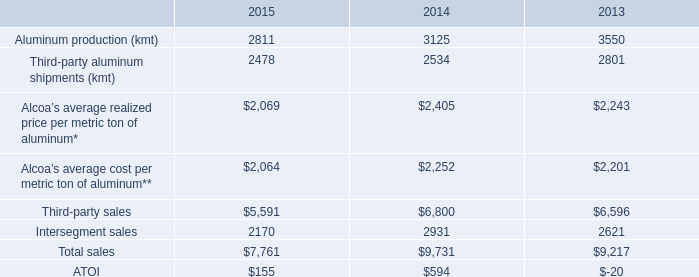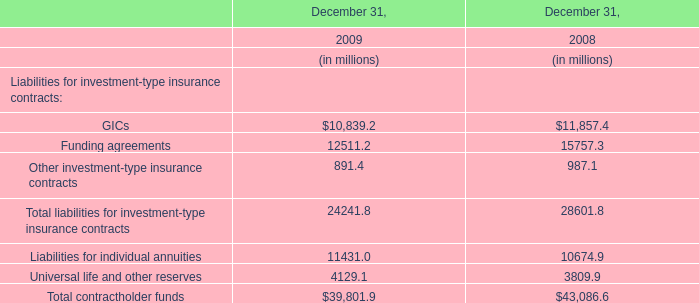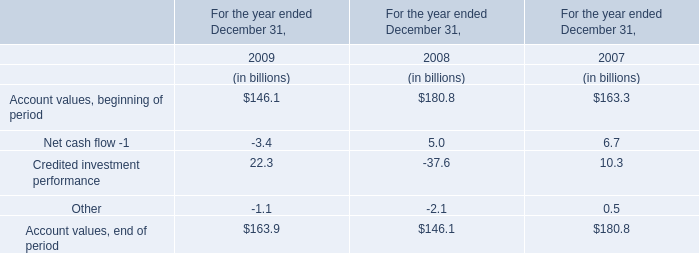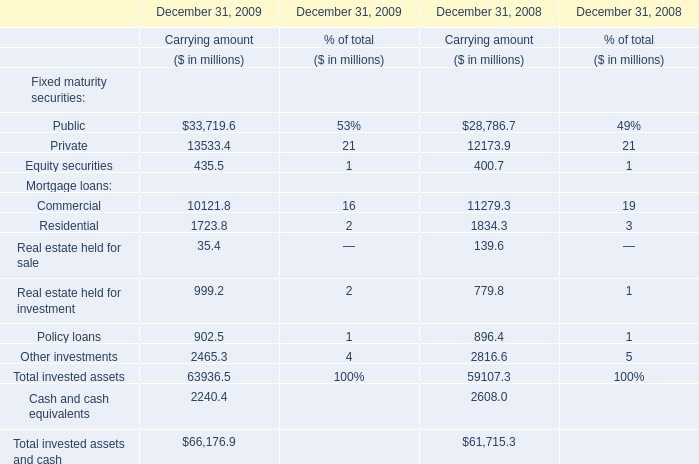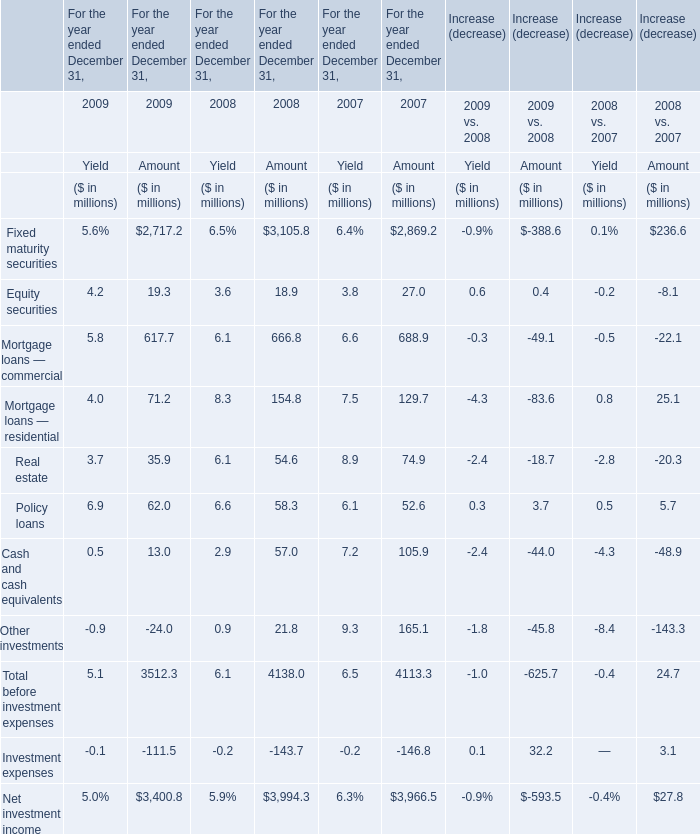What is the sum of Mortgage loans — residential in the range of 1and 100 in 2009?For the year ended December 31, (in million) 
Computations: (4 + 71.2)
Answer: 75.2. 